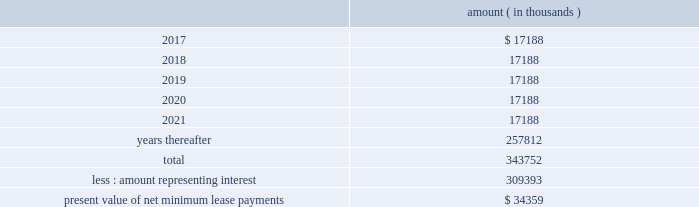Entergy corporation and subsidiaries notes to financial statements liability to $ 60 million , and recorded the $ 2.7 million difference as a credit to interest expense .
The $ 60 million remaining liability was eliminated upon payment of the cash portion of the purchase price .
As of december 31 , 2016 , entergy louisiana , in connection with the waterford 3 lease obligation , had a future minimum lease payment ( reflecting an interest rate of 8.09% ( 8.09 % ) ) of $ 57.5 million , including $ 2.3 million in interest , due january 2017 that is recorded as long-term debt .
In february 2017 the leases were terminated and the leased assets were conveyed to entergy louisiana .
Grand gulf lease obligations in 1988 , in two separate but substantially identical transactions , system energy sold and leased back undivided ownership interests in grand gulf for the aggregate sum of $ 500 million .
The initial term of the leases expired in july 2015 .
System energy renewed the leases for fair market value with renewal terms expiring in july 2036 .
At the end of the new lease renewal terms , system energy has the option to repurchase the leased interests in grand gulf or renew the leases at fair market value .
In the event that system energy does not renew or purchase the interests , system energy would surrender such interests and their associated entitlement of grand gulf 2019s capacity and energy .
System energy is required to report the sale-leaseback as a financing transaction in its financial statements .
For financial reporting purposes , system energy expenses the interest portion of the lease obligation and the plant depreciation .
However , operating revenues include the recovery of the lease payments because the transactions are accounted for as a sale and leaseback for ratemaking purposes .
Consistent with a recommendation contained in a ferc audit report , system energy initially recorded as a net regulatory asset the difference between the recovery of the lease payments and the amounts expensed for interest and depreciation and continues to record this difference as a regulatory asset or liability on an ongoing basis , resulting in a zero net balance for the regulatory asset at the end of the lease term .
The amount was a net regulatory liability of $ 55.6 million and $ 55.6 million as of december 31 , 2016 and 2015 , respectively .
As of december 31 , 2016 , system energy , in connection with the grand gulf sale and leaseback transactions , had future minimum lease payments ( reflecting an implicit rate of 5.13% ( 5.13 % ) ) that are recorded as long-term debt , as follows : amount ( in thousands ) .

What are the implicit interest costs for the lease payments due after 2021 , in thousands? 
Computations: ((5.13 / 100) * 257812)
Answer: 13225.7556. 